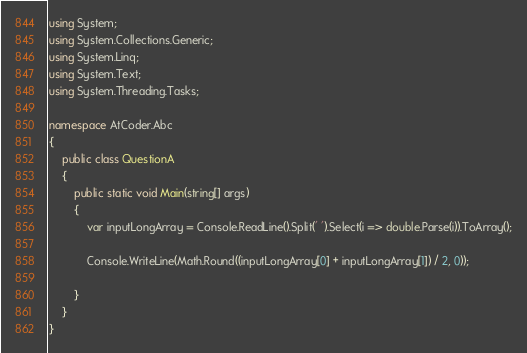<code> <loc_0><loc_0><loc_500><loc_500><_C#_>using System;
using System.Collections.Generic;
using System.Linq;
using System.Text;
using System.Threading.Tasks;

namespace AtCoder.Abc
{
    public class QuestionA
    {
        public static void Main(string[] args)
        {
            var inputLongArray = Console.ReadLine().Split(' ').Select(i => double.Parse(i)).ToArray();

            Console.WriteLine(Math.Round((inputLongArray[0] + inputLongArray[1]) / 2, 0));

        }
    }
}
</code> 